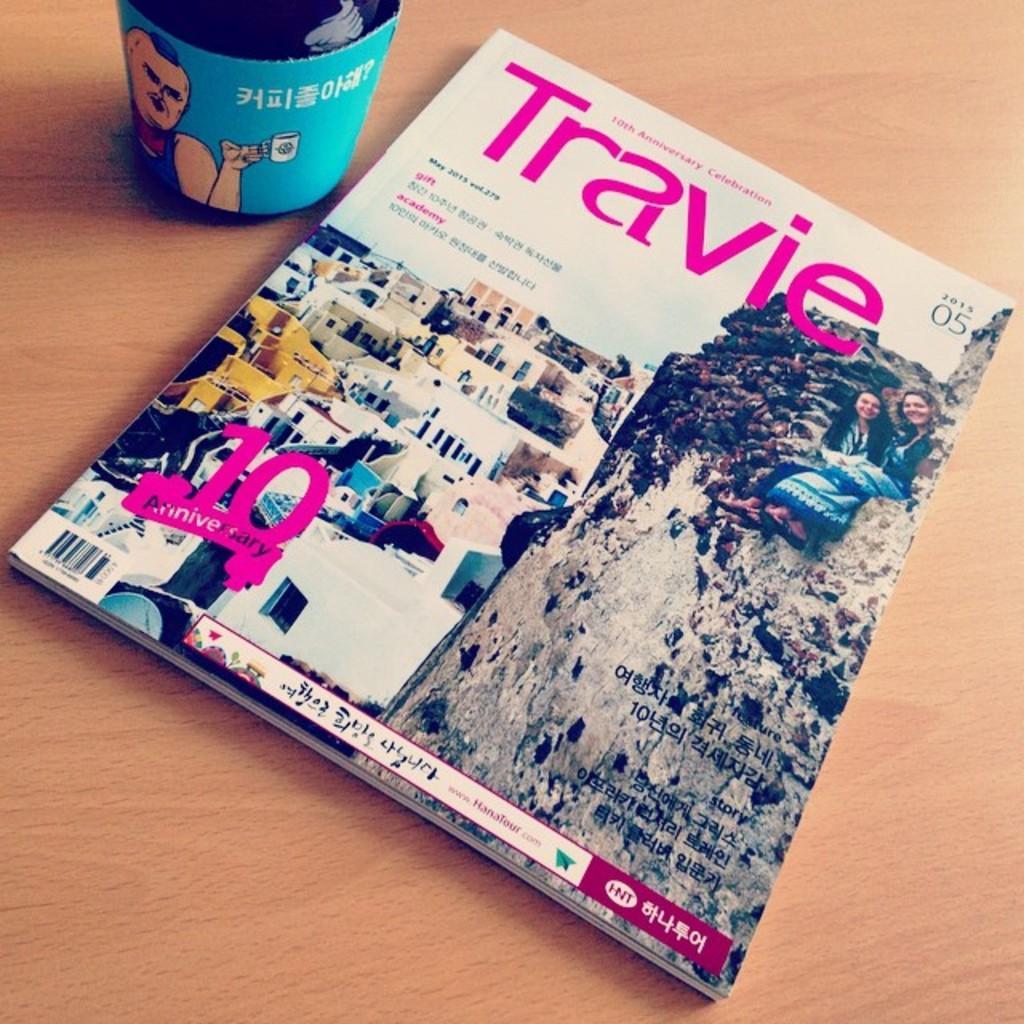Could you give a brief overview of what you see in this image? On a table,there is a magazine and beside the magazine there is a cup,on the magazine there are images of a hill and few houses. On the hill there are two women,they are sitting and smiling. 